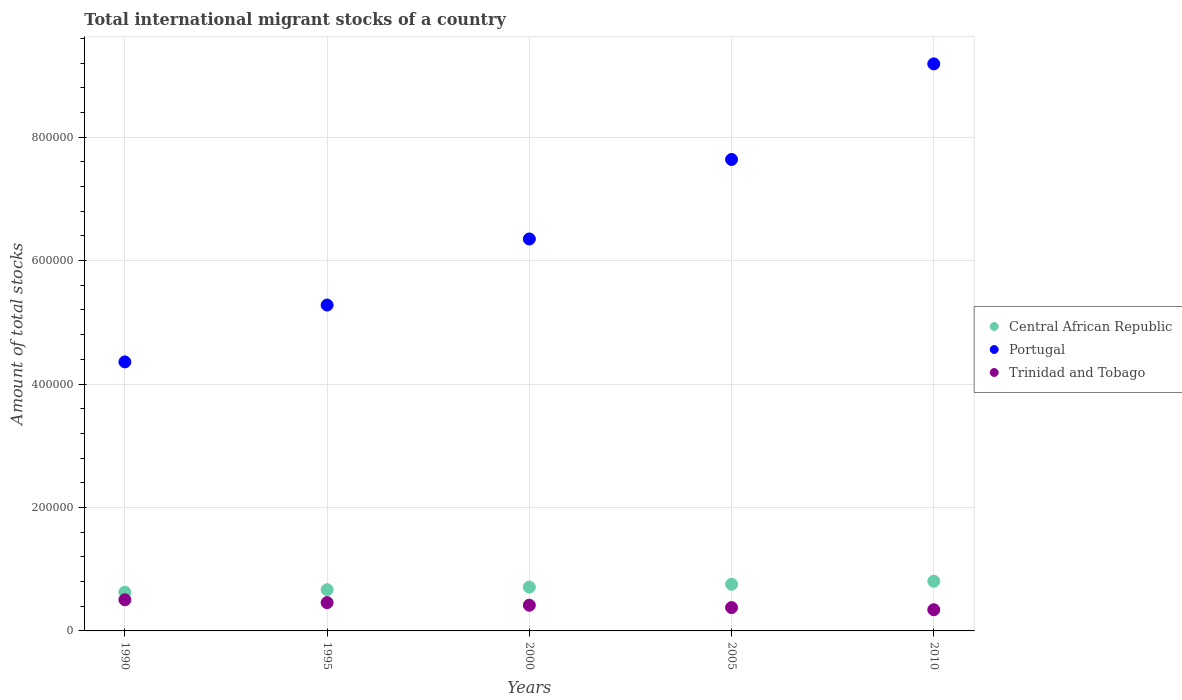Is the number of dotlines equal to the number of legend labels?
Your answer should be compact. Yes. What is the amount of total stocks in in Portugal in 1990?
Offer a very short reply. 4.36e+05. Across all years, what is the maximum amount of total stocks in in Central African Republic?
Provide a succinct answer. 8.05e+04. Across all years, what is the minimum amount of total stocks in in Portugal?
Your answer should be very brief. 4.36e+05. What is the total amount of total stocks in in Central African Republic in the graph?
Your answer should be compact. 3.57e+05. What is the difference between the amount of total stocks in in Central African Republic in 2000 and that in 2005?
Offer a terse response. -4575. What is the difference between the amount of total stocks in in Trinidad and Tobago in 2000 and the amount of total stocks in in Portugal in 2010?
Offer a terse response. -8.77e+05. What is the average amount of total stocks in in Portugal per year?
Provide a short and direct response. 6.56e+05. In the year 1995, what is the difference between the amount of total stocks in in Trinidad and Tobago and amount of total stocks in in Portugal?
Your answer should be compact. -4.82e+05. What is the ratio of the amount of total stocks in in Central African Republic in 2000 to that in 2010?
Your response must be concise. 0.88. Is the amount of total stocks in in Trinidad and Tobago in 1990 less than that in 2010?
Ensure brevity in your answer.  No. What is the difference between the highest and the second highest amount of total stocks in in Trinidad and Tobago?
Your answer should be compact. 4640. What is the difference between the highest and the lowest amount of total stocks in in Trinidad and Tobago?
Ensure brevity in your answer.  1.62e+04. In how many years, is the amount of total stocks in in Trinidad and Tobago greater than the average amount of total stocks in in Trinidad and Tobago taken over all years?
Your response must be concise. 2. Is it the case that in every year, the sum of the amount of total stocks in in Central African Republic and amount of total stocks in in Trinidad and Tobago  is greater than the amount of total stocks in in Portugal?
Provide a short and direct response. No. Does the amount of total stocks in in Trinidad and Tobago monotonically increase over the years?
Provide a succinct answer. No. Is the amount of total stocks in in Trinidad and Tobago strictly greater than the amount of total stocks in in Central African Republic over the years?
Offer a terse response. No. Is the amount of total stocks in in Central African Republic strictly less than the amount of total stocks in in Portugal over the years?
Give a very brief answer. Yes. How many dotlines are there?
Your answer should be very brief. 3. How many years are there in the graph?
Your response must be concise. 5. What is the difference between two consecutive major ticks on the Y-axis?
Your response must be concise. 2.00e+05. Does the graph contain any zero values?
Your answer should be compact. No. Does the graph contain grids?
Give a very brief answer. Yes. How many legend labels are there?
Provide a short and direct response. 3. What is the title of the graph?
Your answer should be very brief. Total international migrant stocks of a country. Does "Ecuador" appear as one of the legend labels in the graph?
Offer a very short reply. No. What is the label or title of the X-axis?
Your response must be concise. Years. What is the label or title of the Y-axis?
Offer a very short reply. Amount of total stocks. What is the Amount of total stocks of Central African Republic in 1990?
Ensure brevity in your answer.  6.27e+04. What is the Amount of total stocks in Portugal in 1990?
Provide a succinct answer. 4.36e+05. What is the Amount of total stocks in Trinidad and Tobago in 1990?
Offer a very short reply. 5.05e+04. What is the Amount of total stocks in Central African Republic in 1995?
Your answer should be compact. 6.68e+04. What is the Amount of total stocks of Portugal in 1995?
Your response must be concise. 5.28e+05. What is the Amount of total stocks of Trinidad and Tobago in 1995?
Make the answer very short. 4.59e+04. What is the Amount of total stocks in Central African Republic in 2000?
Offer a very short reply. 7.10e+04. What is the Amount of total stocks in Portugal in 2000?
Provide a succinct answer. 6.35e+05. What is the Amount of total stocks in Trinidad and Tobago in 2000?
Ensure brevity in your answer.  4.16e+04. What is the Amount of total stocks of Central African Republic in 2005?
Make the answer very short. 7.56e+04. What is the Amount of total stocks in Portugal in 2005?
Provide a succinct answer. 7.64e+05. What is the Amount of total stocks of Trinidad and Tobago in 2005?
Offer a very short reply. 3.78e+04. What is the Amount of total stocks in Central African Republic in 2010?
Give a very brief answer. 8.05e+04. What is the Amount of total stocks in Portugal in 2010?
Provide a succinct answer. 9.19e+05. What is the Amount of total stocks in Trinidad and Tobago in 2010?
Your answer should be compact. 3.43e+04. Across all years, what is the maximum Amount of total stocks of Central African Republic?
Offer a very short reply. 8.05e+04. Across all years, what is the maximum Amount of total stocks in Portugal?
Your response must be concise. 9.19e+05. Across all years, what is the maximum Amount of total stocks of Trinidad and Tobago?
Ensure brevity in your answer.  5.05e+04. Across all years, what is the minimum Amount of total stocks of Central African Republic?
Provide a succinct answer. 6.27e+04. Across all years, what is the minimum Amount of total stocks of Portugal?
Offer a terse response. 4.36e+05. Across all years, what is the minimum Amount of total stocks in Trinidad and Tobago?
Offer a terse response. 3.43e+04. What is the total Amount of total stocks in Central African Republic in the graph?
Give a very brief answer. 3.57e+05. What is the total Amount of total stocks in Portugal in the graph?
Provide a short and direct response. 3.28e+06. What is the total Amount of total stocks in Trinidad and Tobago in the graph?
Provide a short and direct response. 2.10e+05. What is the difference between the Amount of total stocks in Central African Republic in 1990 and that in 1995?
Your response must be concise. -4038. What is the difference between the Amount of total stocks of Portugal in 1990 and that in 1995?
Offer a very short reply. -9.21e+04. What is the difference between the Amount of total stocks in Trinidad and Tobago in 1990 and that in 1995?
Keep it short and to the point. 4640. What is the difference between the Amount of total stocks in Central African Republic in 1990 and that in 2000?
Your response must be concise. -8335. What is the difference between the Amount of total stocks in Portugal in 1990 and that in 2000?
Provide a short and direct response. -1.99e+05. What is the difference between the Amount of total stocks in Trinidad and Tobago in 1990 and that in 2000?
Your answer should be compact. 8854. What is the difference between the Amount of total stocks of Central African Republic in 1990 and that in 2005?
Offer a terse response. -1.29e+04. What is the difference between the Amount of total stocks in Portugal in 1990 and that in 2005?
Your answer should be very brief. -3.28e+05. What is the difference between the Amount of total stocks in Trinidad and Tobago in 1990 and that in 2005?
Offer a very short reply. 1.27e+04. What is the difference between the Amount of total stocks in Central African Republic in 1990 and that in 2010?
Keep it short and to the point. -1.78e+04. What is the difference between the Amount of total stocks in Portugal in 1990 and that in 2010?
Ensure brevity in your answer.  -4.83e+05. What is the difference between the Amount of total stocks of Trinidad and Tobago in 1990 and that in 2010?
Your answer should be compact. 1.62e+04. What is the difference between the Amount of total stocks in Central African Republic in 1995 and that in 2000?
Your answer should be compact. -4297. What is the difference between the Amount of total stocks of Portugal in 1995 and that in 2000?
Your answer should be very brief. -1.07e+05. What is the difference between the Amount of total stocks of Trinidad and Tobago in 1995 and that in 2000?
Keep it short and to the point. 4214. What is the difference between the Amount of total stocks in Central African Republic in 1995 and that in 2005?
Ensure brevity in your answer.  -8872. What is the difference between the Amount of total stocks in Portugal in 1995 and that in 2005?
Give a very brief answer. -2.36e+05. What is the difference between the Amount of total stocks in Trinidad and Tobago in 1995 and that in 2005?
Offer a very short reply. 8041. What is the difference between the Amount of total stocks in Central African Republic in 1995 and that in 2010?
Your answer should be very brief. -1.37e+04. What is the difference between the Amount of total stocks in Portugal in 1995 and that in 2010?
Your answer should be compact. -3.91e+05. What is the difference between the Amount of total stocks in Trinidad and Tobago in 1995 and that in 2010?
Your answer should be compact. 1.15e+04. What is the difference between the Amount of total stocks in Central African Republic in 2000 and that in 2005?
Offer a very short reply. -4575. What is the difference between the Amount of total stocks of Portugal in 2000 and that in 2005?
Make the answer very short. -1.29e+05. What is the difference between the Amount of total stocks in Trinidad and Tobago in 2000 and that in 2005?
Offer a terse response. 3827. What is the difference between the Amount of total stocks of Central African Republic in 2000 and that in 2010?
Your response must be concise. -9444. What is the difference between the Amount of total stocks of Portugal in 2000 and that in 2010?
Provide a short and direct response. -2.84e+05. What is the difference between the Amount of total stocks in Trinidad and Tobago in 2000 and that in 2010?
Your answer should be compact. 7302. What is the difference between the Amount of total stocks of Central African Republic in 2005 and that in 2010?
Provide a short and direct response. -4869. What is the difference between the Amount of total stocks of Portugal in 2005 and that in 2010?
Your answer should be compact. -1.55e+05. What is the difference between the Amount of total stocks of Trinidad and Tobago in 2005 and that in 2010?
Your answer should be very brief. 3475. What is the difference between the Amount of total stocks in Central African Republic in 1990 and the Amount of total stocks in Portugal in 1995?
Provide a short and direct response. -4.65e+05. What is the difference between the Amount of total stocks of Central African Republic in 1990 and the Amount of total stocks of Trinidad and Tobago in 1995?
Give a very brief answer. 1.68e+04. What is the difference between the Amount of total stocks in Portugal in 1990 and the Amount of total stocks in Trinidad and Tobago in 1995?
Offer a terse response. 3.90e+05. What is the difference between the Amount of total stocks of Central African Republic in 1990 and the Amount of total stocks of Portugal in 2000?
Offer a very short reply. -5.72e+05. What is the difference between the Amount of total stocks in Central African Republic in 1990 and the Amount of total stocks in Trinidad and Tobago in 2000?
Give a very brief answer. 2.11e+04. What is the difference between the Amount of total stocks in Portugal in 1990 and the Amount of total stocks in Trinidad and Tobago in 2000?
Give a very brief answer. 3.94e+05. What is the difference between the Amount of total stocks of Central African Republic in 1990 and the Amount of total stocks of Portugal in 2005?
Your answer should be compact. -7.01e+05. What is the difference between the Amount of total stocks of Central African Republic in 1990 and the Amount of total stocks of Trinidad and Tobago in 2005?
Give a very brief answer. 2.49e+04. What is the difference between the Amount of total stocks in Portugal in 1990 and the Amount of total stocks in Trinidad and Tobago in 2005?
Provide a succinct answer. 3.98e+05. What is the difference between the Amount of total stocks in Central African Republic in 1990 and the Amount of total stocks in Portugal in 2010?
Make the answer very short. -8.56e+05. What is the difference between the Amount of total stocks in Central African Republic in 1990 and the Amount of total stocks in Trinidad and Tobago in 2010?
Make the answer very short. 2.84e+04. What is the difference between the Amount of total stocks in Portugal in 1990 and the Amount of total stocks in Trinidad and Tobago in 2010?
Your response must be concise. 4.01e+05. What is the difference between the Amount of total stocks in Central African Republic in 1995 and the Amount of total stocks in Portugal in 2000?
Provide a short and direct response. -5.68e+05. What is the difference between the Amount of total stocks of Central African Republic in 1995 and the Amount of total stocks of Trinidad and Tobago in 2000?
Your response must be concise. 2.51e+04. What is the difference between the Amount of total stocks of Portugal in 1995 and the Amount of total stocks of Trinidad and Tobago in 2000?
Your response must be concise. 4.86e+05. What is the difference between the Amount of total stocks in Central African Republic in 1995 and the Amount of total stocks in Portugal in 2005?
Provide a succinct answer. -6.97e+05. What is the difference between the Amount of total stocks of Central African Republic in 1995 and the Amount of total stocks of Trinidad and Tobago in 2005?
Give a very brief answer. 2.89e+04. What is the difference between the Amount of total stocks of Portugal in 1995 and the Amount of total stocks of Trinidad and Tobago in 2005?
Provide a succinct answer. 4.90e+05. What is the difference between the Amount of total stocks in Central African Republic in 1995 and the Amount of total stocks in Portugal in 2010?
Make the answer very short. -8.52e+05. What is the difference between the Amount of total stocks of Central African Republic in 1995 and the Amount of total stocks of Trinidad and Tobago in 2010?
Make the answer very short. 3.24e+04. What is the difference between the Amount of total stocks of Portugal in 1995 and the Amount of total stocks of Trinidad and Tobago in 2010?
Keep it short and to the point. 4.94e+05. What is the difference between the Amount of total stocks in Central African Republic in 2000 and the Amount of total stocks in Portugal in 2005?
Your answer should be very brief. -6.93e+05. What is the difference between the Amount of total stocks of Central African Republic in 2000 and the Amount of total stocks of Trinidad and Tobago in 2005?
Your response must be concise. 3.32e+04. What is the difference between the Amount of total stocks of Portugal in 2000 and the Amount of total stocks of Trinidad and Tobago in 2005?
Ensure brevity in your answer.  5.97e+05. What is the difference between the Amount of total stocks of Central African Republic in 2000 and the Amount of total stocks of Portugal in 2010?
Your answer should be compact. -8.48e+05. What is the difference between the Amount of total stocks of Central African Republic in 2000 and the Amount of total stocks of Trinidad and Tobago in 2010?
Ensure brevity in your answer.  3.67e+04. What is the difference between the Amount of total stocks in Portugal in 2000 and the Amount of total stocks in Trinidad and Tobago in 2010?
Give a very brief answer. 6.01e+05. What is the difference between the Amount of total stocks in Central African Republic in 2005 and the Amount of total stocks in Portugal in 2010?
Offer a terse response. -8.43e+05. What is the difference between the Amount of total stocks in Central African Republic in 2005 and the Amount of total stocks in Trinidad and Tobago in 2010?
Keep it short and to the point. 4.13e+04. What is the difference between the Amount of total stocks of Portugal in 2005 and the Amount of total stocks of Trinidad and Tobago in 2010?
Provide a succinct answer. 7.29e+05. What is the average Amount of total stocks in Central African Republic per year?
Ensure brevity in your answer.  7.13e+04. What is the average Amount of total stocks in Portugal per year?
Your answer should be very brief. 6.56e+05. What is the average Amount of total stocks in Trinidad and Tobago per year?
Provide a short and direct response. 4.20e+04. In the year 1990, what is the difference between the Amount of total stocks of Central African Republic and Amount of total stocks of Portugal?
Provide a succinct answer. -3.73e+05. In the year 1990, what is the difference between the Amount of total stocks in Central African Republic and Amount of total stocks in Trinidad and Tobago?
Offer a very short reply. 1.22e+04. In the year 1990, what is the difference between the Amount of total stocks in Portugal and Amount of total stocks in Trinidad and Tobago?
Provide a succinct answer. 3.85e+05. In the year 1995, what is the difference between the Amount of total stocks of Central African Republic and Amount of total stocks of Portugal?
Your answer should be compact. -4.61e+05. In the year 1995, what is the difference between the Amount of total stocks in Central African Republic and Amount of total stocks in Trinidad and Tobago?
Provide a succinct answer. 2.09e+04. In the year 1995, what is the difference between the Amount of total stocks of Portugal and Amount of total stocks of Trinidad and Tobago?
Give a very brief answer. 4.82e+05. In the year 2000, what is the difference between the Amount of total stocks of Central African Republic and Amount of total stocks of Portugal?
Provide a short and direct response. -5.64e+05. In the year 2000, what is the difference between the Amount of total stocks of Central African Republic and Amount of total stocks of Trinidad and Tobago?
Make the answer very short. 2.94e+04. In the year 2000, what is the difference between the Amount of total stocks in Portugal and Amount of total stocks in Trinidad and Tobago?
Ensure brevity in your answer.  5.93e+05. In the year 2005, what is the difference between the Amount of total stocks of Central African Republic and Amount of total stocks of Portugal?
Your answer should be very brief. -6.88e+05. In the year 2005, what is the difference between the Amount of total stocks in Central African Republic and Amount of total stocks in Trinidad and Tobago?
Keep it short and to the point. 3.78e+04. In the year 2005, what is the difference between the Amount of total stocks in Portugal and Amount of total stocks in Trinidad and Tobago?
Your answer should be very brief. 7.26e+05. In the year 2010, what is the difference between the Amount of total stocks in Central African Republic and Amount of total stocks in Portugal?
Offer a terse response. -8.38e+05. In the year 2010, what is the difference between the Amount of total stocks of Central African Republic and Amount of total stocks of Trinidad and Tobago?
Your answer should be compact. 4.61e+04. In the year 2010, what is the difference between the Amount of total stocks in Portugal and Amount of total stocks in Trinidad and Tobago?
Your response must be concise. 8.84e+05. What is the ratio of the Amount of total stocks of Central African Republic in 1990 to that in 1995?
Your response must be concise. 0.94. What is the ratio of the Amount of total stocks of Portugal in 1990 to that in 1995?
Keep it short and to the point. 0.83. What is the ratio of the Amount of total stocks in Trinidad and Tobago in 1990 to that in 1995?
Your answer should be compact. 1.1. What is the ratio of the Amount of total stocks of Central African Republic in 1990 to that in 2000?
Offer a very short reply. 0.88. What is the ratio of the Amount of total stocks of Portugal in 1990 to that in 2000?
Offer a terse response. 0.69. What is the ratio of the Amount of total stocks in Trinidad and Tobago in 1990 to that in 2000?
Make the answer very short. 1.21. What is the ratio of the Amount of total stocks in Central African Republic in 1990 to that in 2005?
Give a very brief answer. 0.83. What is the ratio of the Amount of total stocks of Portugal in 1990 to that in 2005?
Provide a short and direct response. 0.57. What is the ratio of the Amount of total stocks in Trinidad and Tobago in 1990 to that in 2005?
Provide a succinct answer. 1.34. What is the ratio of the Amount of total stocks of Central African Republic in 1990 to that in 2010?
Offer a very short reply. 0.78. What is the ratio of the Amount of total stocks in Portugal in 1990 to that in 2010?
Your response must be concise. 0.47. What is the ratio of the Amount of total stocks of Trinidad and Tobago in 1990 to that in 2010?
Your response must be concise. 1.47. What is the ratio of the Amount of total stocks in Central African Republic in 1995 to that in 2000?
Offer a terse response. 0.94. What is the ratio of the Amount of total stocks of Portugal in 1995 to that in 2000?
Your answer should be very brief. 0.83. What is the ratio of the Amount of total stocks of Trinidad and Tobago in 1995 to that in 2000?
Offer a very short reply. 1.1. What is the ratio of the Amount of total stocks of Central African Republic in 1995 to that in 2005?
Your answer should be compact. 0.88. What is the ratio of the Amount of total stocks of Portugal in 1995 to that in 2005?
Provide a short and direct response. 0.69. What is the ratio of the Amount of total stocks in Trinidad and Tobago in 1995 to that in 2005?
Offer a very short reply. 1.21. What is the ratio of the Amount of total stocks of Central African Republic in 1995 to that in 2010?
Provide a short and direct response. 0.83. What is the ratio of the Amount of total stocks of Portugal in 1995 to that in 2010?
Keep it short and to the point. 0.57. What is the ratio of the Amount of total stocks of Trinidad and Tobago in 1995 to that in 2010?
Keep it short and to the point. 1.34. What is the ratio of the Amount of total stocks of Central African Republic in 2000 to that in 2005?
Provide a succinct answer. 0.94. What is the ratio of the Amount of total stocks of Portugal in 2000 to that in 2005?
Offer a very short reply. 0.83. What is the ratio of the Amount of total stocks of Trinidad and Tobago in 2000 to that in 2005?
Keep it short and to the point. 1.1. What is the ratio of the Amount of total stocks in Central African Republic in 2000 to that in 2010?
Give a very brief answer. 0.88. What is the ratio of the Amount of total stocks in Portugal in 2000 to that in 2010?
Offer a terse response. 0.69. What is the ratio of the Amount of total stocks of Trinidad and Tobago in 2000 to that in 2010?
Your answer should be compact. 1.21. What is the ratio of the Amount of total stocks of Central African Republic in 2005 to that in 2010?
Your answer should be very brief. 0.94. What is the ratio of the Amount of total stocks of Portugal in 2005 to that in 2010?
Your response must be concise. 0.83. What is the ratio of the Amount of total stocks of Trinidad and Tobago in 2005 to that in 2010?
Your answer should be compact. 1.1. What is the difference between the highest and the second highest Amount of total stocks in Central African Republic?
Provide a succinct answer. 4869. What is the difference between the highest and the second highest Amount of total stocks in Portugal?
Your answer should be very brief. 1.55e+05. What is the difference between the highest and the second highest Amount of total stocks in Trinidad and Tobago?
Provide a succinct answer. 4640. What is the difference between the highest and the lowest Amount of total stocks in Central African Republic?
Provide a short and direct response. 1.78e+04. What is the difference between the highest and the lowest Amount of total stocks of Portugal?
Offer a very short reply. 4.83e+05. What is the difference between the highest and the lowest Amount of total stocks of Trinidad and Tobago?
Make the answer very short. 1.62e+04. 